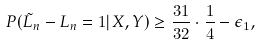<formula> <loc_0><loc_0><loc_500><loc_500>P ( \tilde { L } _ { n } - L _ { n } = 1 | X , Y ) \geq \frac { 3 1 } { 3 2 } \cdot \frac { 1 } { 4 } - \epsilon _ { 1 } ,</formula> 